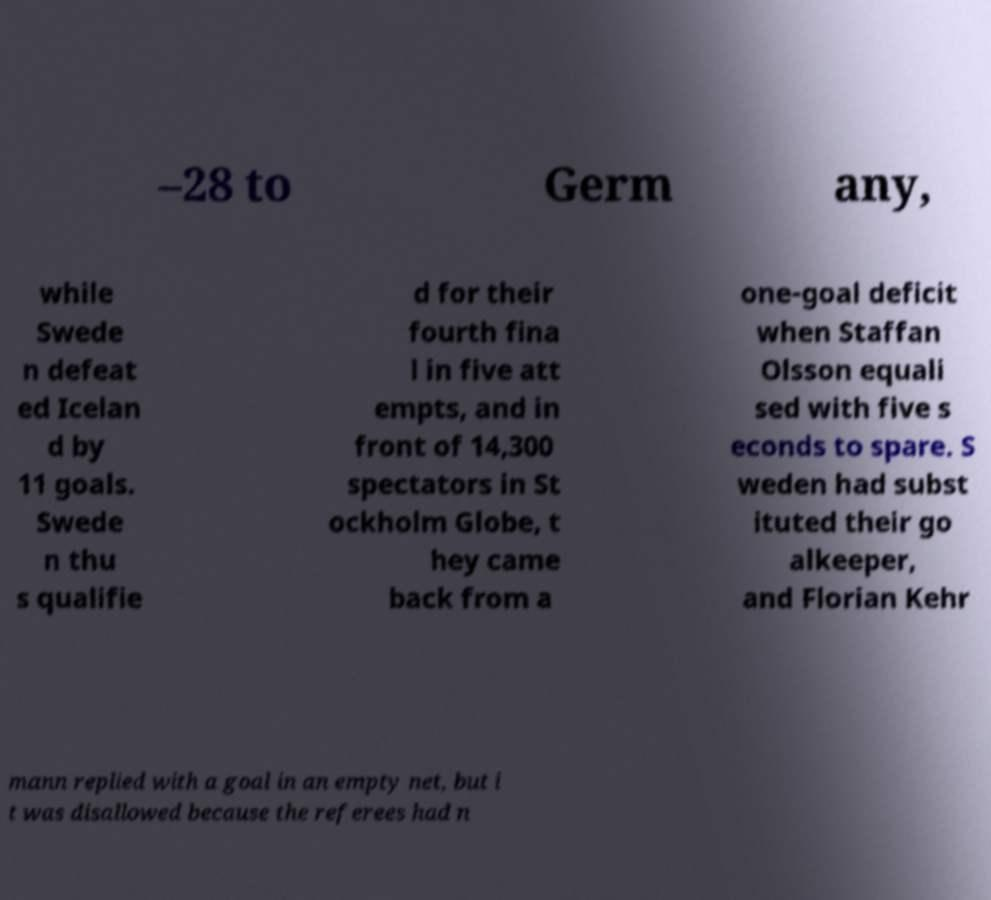Could you extract and type out the text from this image? –28 to Germ any, while Swede n defeat ed Icelan d by 11 goals. Swede n thu s qualifie d for their fourth fina l in five att empts, and in front of 14,300 spectators in St ockholm Globe, t hey came back from a one-goal deficit when Staffan Olsson equali sed with five s econds to spare. S weden had subst ituted their go alkeeper, and Florian Kehr mann replied with a goal in an empty net, but i t was disallowed because the referees had n 